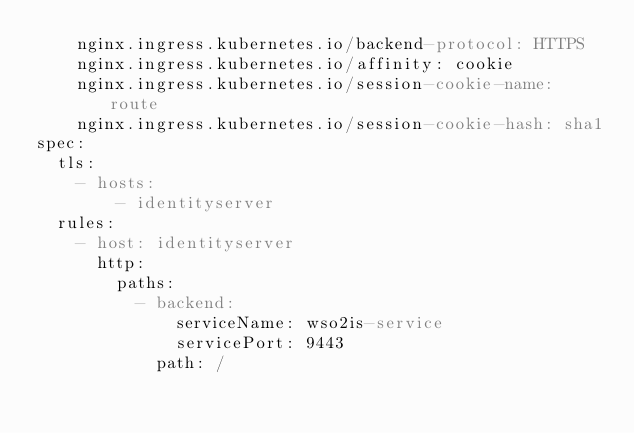Convert code to text. <code><loc_0><loc_0><loc_500><loc_500><_YAML_>    nginx.ingress.kubernetes.io/backend-protocol: HTTPS
    nginx.ingress.kubernetes.io/affinity: cookie
    nginx.ingress.kubernetes.io/session-cookie-name: route
    nginx.ingress.kubernetes.io/session-cookie-hash: sha1
spec:
  tls:
    - hosts:
        - identityserver
  rules:
    - host: identityserver
      http:
        paths:
          - backend:
              serviceName: wso2is-service
              servicePort: 9443
            path: /</code> 